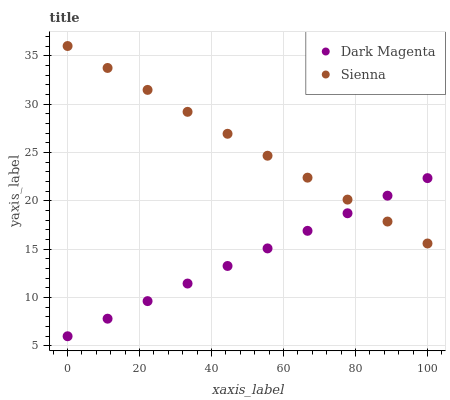Does Dark Magenta have the minimum area under the curve?
Answer yes or no. Yes. Does Sienna have the maximum area under the curve?
Answer yes or no. Yes. Does Dark Magenta have the maximum area under the curve?
Answer yes or no. No. Is Dark Magenta the smoothest?
Answer yes or no. Yes. Is Sienna the roughest?
Answer yes or no. Yes. Is Dark Magenta the roughest?
Answer yes or no. No. Does Dark Magenta have the lowest value?
Answer yes or no. Yes. Does Sienna have the highest value?
Answer yes or no. Yes. Does Dark Magenta have the highest value?
Answer yes or no. No. Does Sienna intersect Dark Magenta?
Answer yes or no. Yes. Is Sienna less than Dark Magenta?
Answer yes or no. No. Is Sienna greater than Dark Magenta?
Answer yes or no. No. 